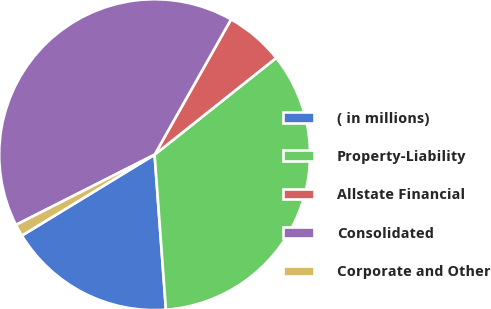Convert chart to OTSL. <chart><loc_0><loc_0><loc_500><loc_500><pie_chart><fcel>( in millions)<fcel>Property-Liability<fcel>Allstate Financial<fcel>Consolidated<fcel>Corporate and Other<nl><fcel>17.45%<fcel>34.54%<fcel>6.12%<fcel>40.65%<fcel>1.25%<nl></chart> 